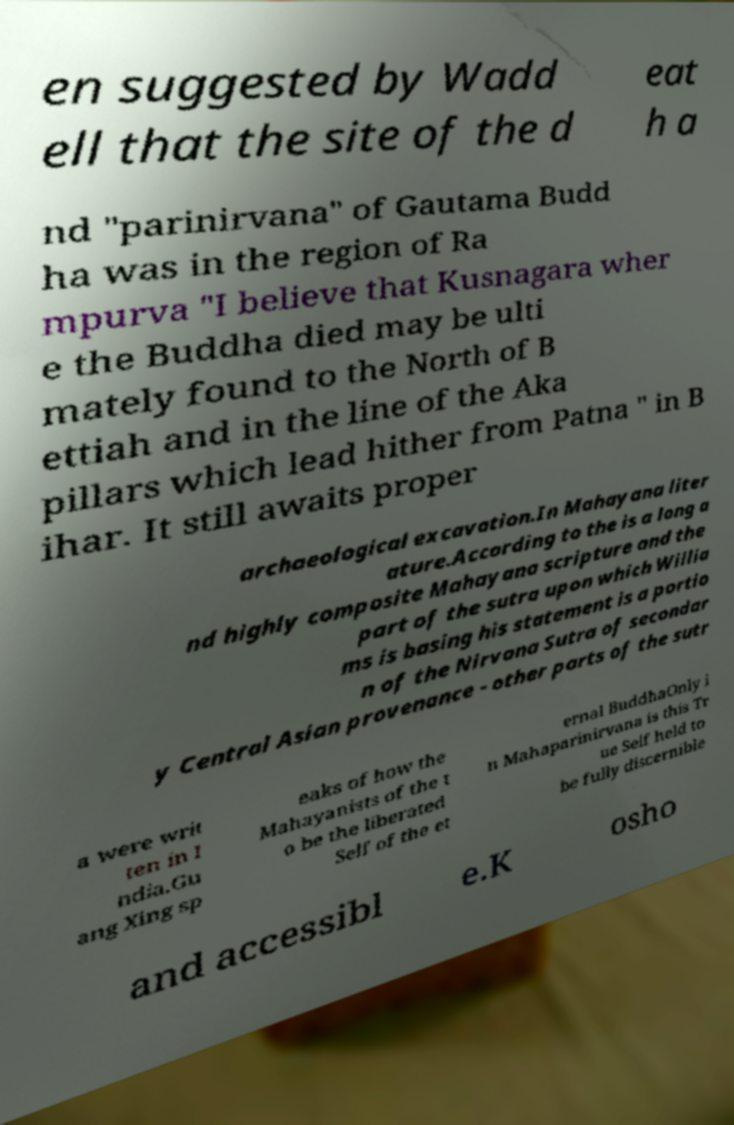Could you assist in decoding the text presented in this image and type it out clearly? en suggested by Wadd ell that the site of the d eat h a nd "parinirvana" of Gautama Budd ha was in the region of Ra mpurva "I believe that Kusnagara wher e the Buddha died may be ulti mately found to the North of B ettiah and in the line of the Aka pillars which lead hither from Patna " in B ihar. It still awaits proper archaeological excavation.In Mahayana liter ature.According to the is a long a nd highly composite Mahayana scripture and the part of the sutra upon which Willia ms is basing his statement is a portio n of the Nirvana Sutra of secondar y Central Asian provenance - other parts of the sutr a were writ ten in I ndia.Gu ang Xing sp eaks of how the Mahayanists of the t o be the liberated Self of the et ernal BuddhaOnly i n Mahaparinirvana is this Tr ue Self held to be fully discernible and accessibl e.K osho 